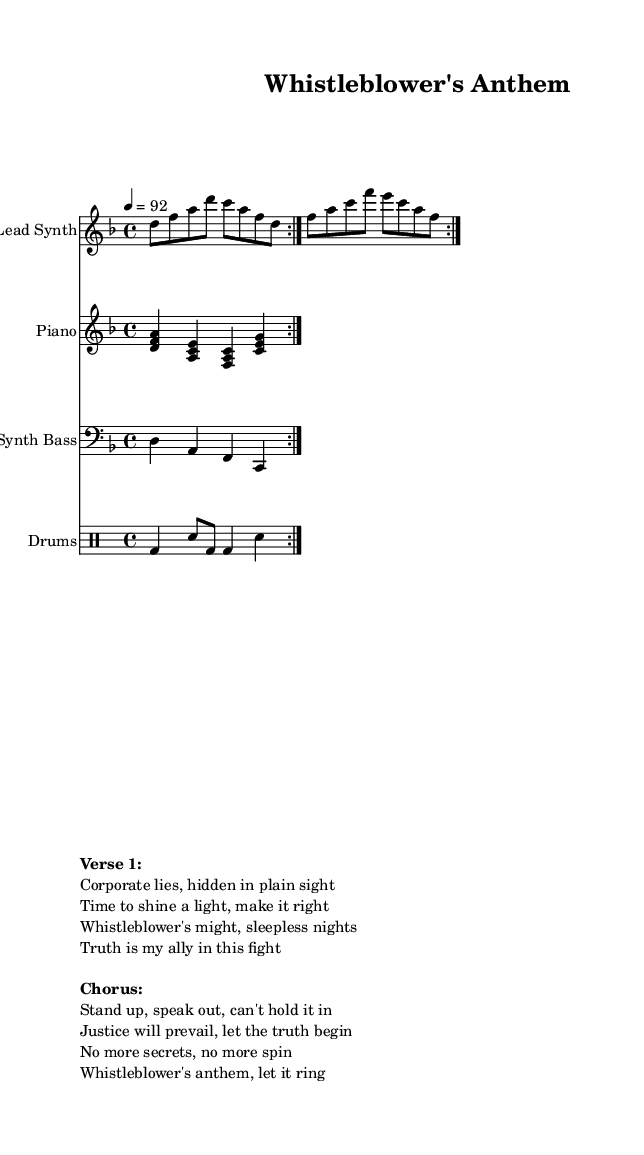What is the key signature of this music? The key signature is D minor, indicated by one flat, which is B flat. In the global section, where the musical parameters are defined, the key signature is explicitly stated as \key d \minor.
Answer: D minor What is the time signature of the piece? The time signature is 4/4, as indicated in the global section of the code with the \time directive. This means there are four beats in each measure, and the quarter note gets one beat.
Answer: 4/4 What is the tempo of the music? The tempo is set at 92 beats per minute, as noted with the \tempo directive specifying "4 = 92". This means the quarter note is played at 92 beats per minute.
Answer: 92 How many volta repetitions are present in the lead synth section? There are 2 volta repetitions indicated by the \repeat volta 2 directive within the lead synth section. This means that the musical segment will be played twice.
Answer: 2 What is the primary theme expressed in the first verse of the lyrics? The theme in the first verse centers around individual struggle and the pursuit of truth against corporate deceit. The lyrics mention “Corporate lies” and “Truth is my ally,” emphasizing the fight for justice and clarity.
Answer: Individual struggle for truth What musical elements contribute to the hip hop genre in this piece? The piece features typical hip hop elements like a strong rhythmic beat provided by the drum patterns, bass lines, and lyrical flow in the verses and chorus. The drum part exhibits a distinct beat, crucial for hip hop music, and the use of synthesizers for melody adds to the genre's feel.
Answer: Strong beats and rhythmic flow What is the function of the chorus in this piece? The chorus functions as the main message or hook of the song, summarizing the call to action for justice and truth, encouraging listeners to "Stand up, speak out." It contrasts the verses with a more memorable and impactful refrain, making it a pivotal part of the structure.
Answer: Main message and call to action 